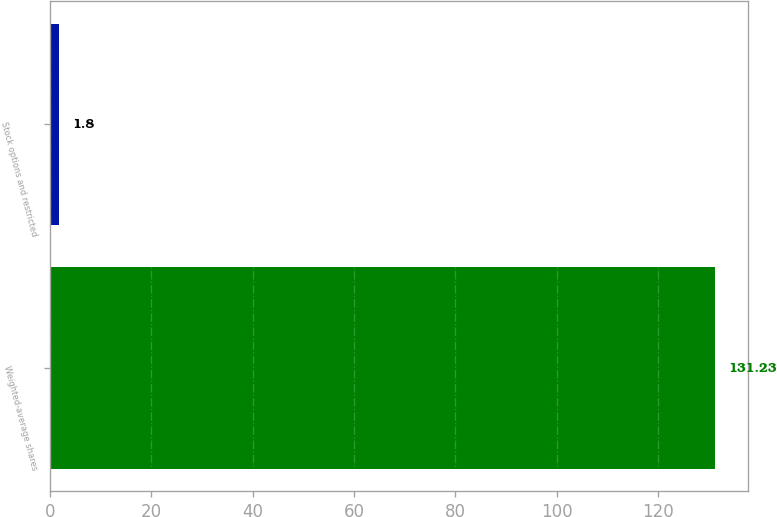<chart> <loc_0><loc_0><loc_500><loc_500><bar_chart><fcel>Weighted-average shares<fcel>Stock options and restricted<nl><fcel>131.23<fcel>1.8<nl></chart> 